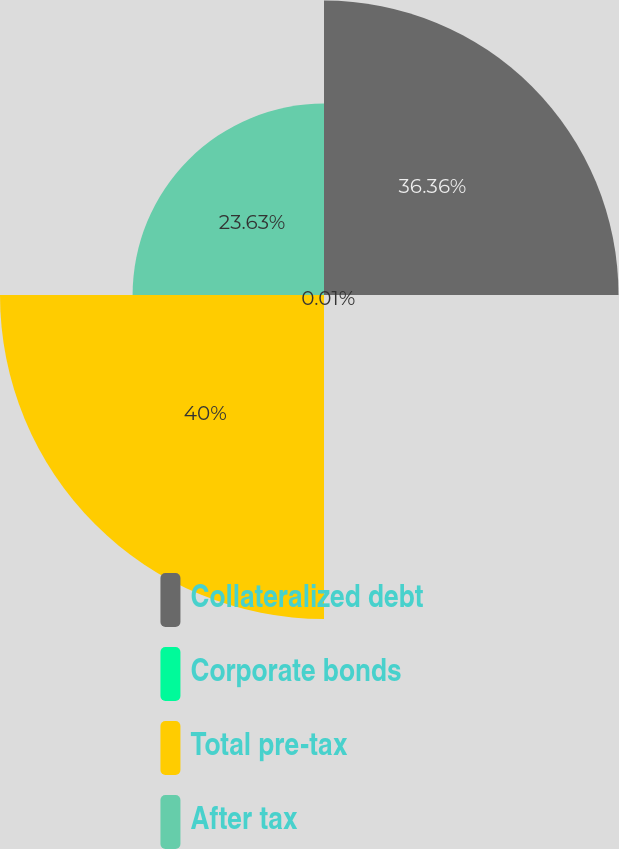Convert chart. <chart><loc_0><loc_0><loc_500><loc_500><pie_chart><fcel>Collateralized debt<fcel>Corporate bonds<fcel>Total pre-tax<fcel>After tax<nl><fcel>36.36%<fcel>0.01%<fcel>40.0%<fcel>23.63%<nl></chart> 